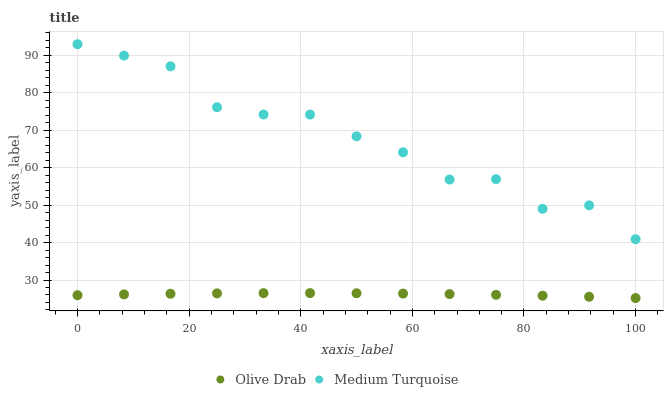Does Olive Drab have the minimum area under the curve?
Answer yes or no. Yes. Does Medium Turquoise have the maximum area under the curve?
Answer yes or no. Yes. Does Olive Drab have the maximum area under the curve?
Answer yes or no. No. Is Olive Drab the smoothest?
Answer yes or no. Yes. Is Medium Turquoise the roughest?
Answer yes or no. Yes. Is Olive Drab the roughest?
Answer yes or no. No. Does Olive Drab have the lowest value?
Answer yes or no. Yes. Does Medium Turquoise have the highest value?
Answer yes or no. Yes. Does Olive Drab have the highest value?
Answer yes or no. No. Is Olive Drab less than Medium Turquoise?
Answer yes or no. Yes. Is Medium Turquoise greater than Olive Drab?
Answer yes or no. Yes. Does Olive Drab intersect Medium Turquoise?
Answer yes or no. No. 